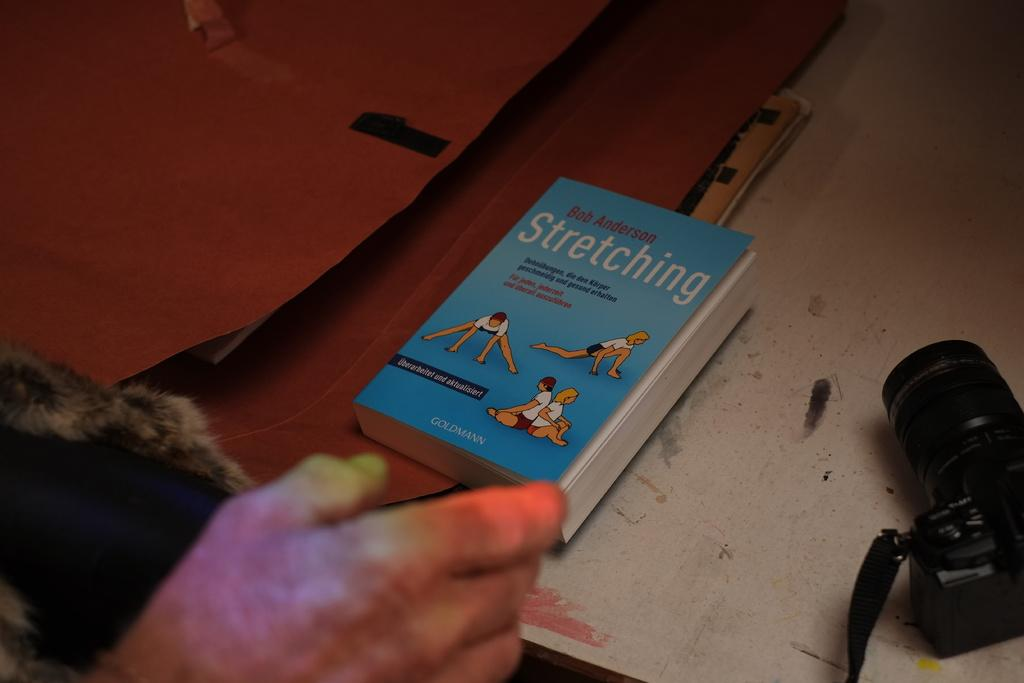<image>
Write a terse but informative summary of the picture. A book by Bob Anderson about stretching is on a desk near a camera. 